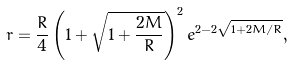<formula> <loc_0><loc_0><loc_500><loc_500>r = \frac { R } { 4 } \left ( 1 + \sqrt { 1 + \frac { 2 M } { R } } \right ) ^ { 2 } e ^ { 2 - 2 \sqrt { 1 + 2 M / R } } ,</formula> 